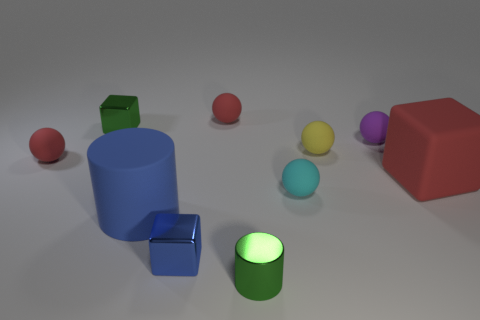Is the color of the small cylinder the same as the matte cube?
Your response must be concise. No. There is a shiny thing that is the same color as the matte cylinder; what is its size?
Offer a very short reply. Small. There is a block that is in front of the big matte object in front of the ball in front of the big red object; what is its material?
Your answer should be compact. Metal. How many things are either yellow shiny spheres or shiny objects?
Ensure brevity in your answer.  3. There is a matte cylinder that is behind the metallic cylinder; does it have the same color as the big object that is behind the small cyan sphere?
Your answer should be compact. No. There is a cyan rubber thing that is the same size as the yellow matte thing; what is its shape?
Offer a very short reply. Sphere. How many things are either big rubber things to the left of the cyan thing or balls that are to the right of the tiny yellow object?
Keep it short and to the point. 2. Is the number of yellow balls less than the number of objects?
Keep it short and to the point. Yes. What is the material of the yellow ball that is the same size as the blue block?
Your answer should be very brief. Rubber. There is a green object behind the big red rubber object; is its size the same as the block that is in front of the cyan rubber object?
Ensure brevity in your answer.  Yes. 